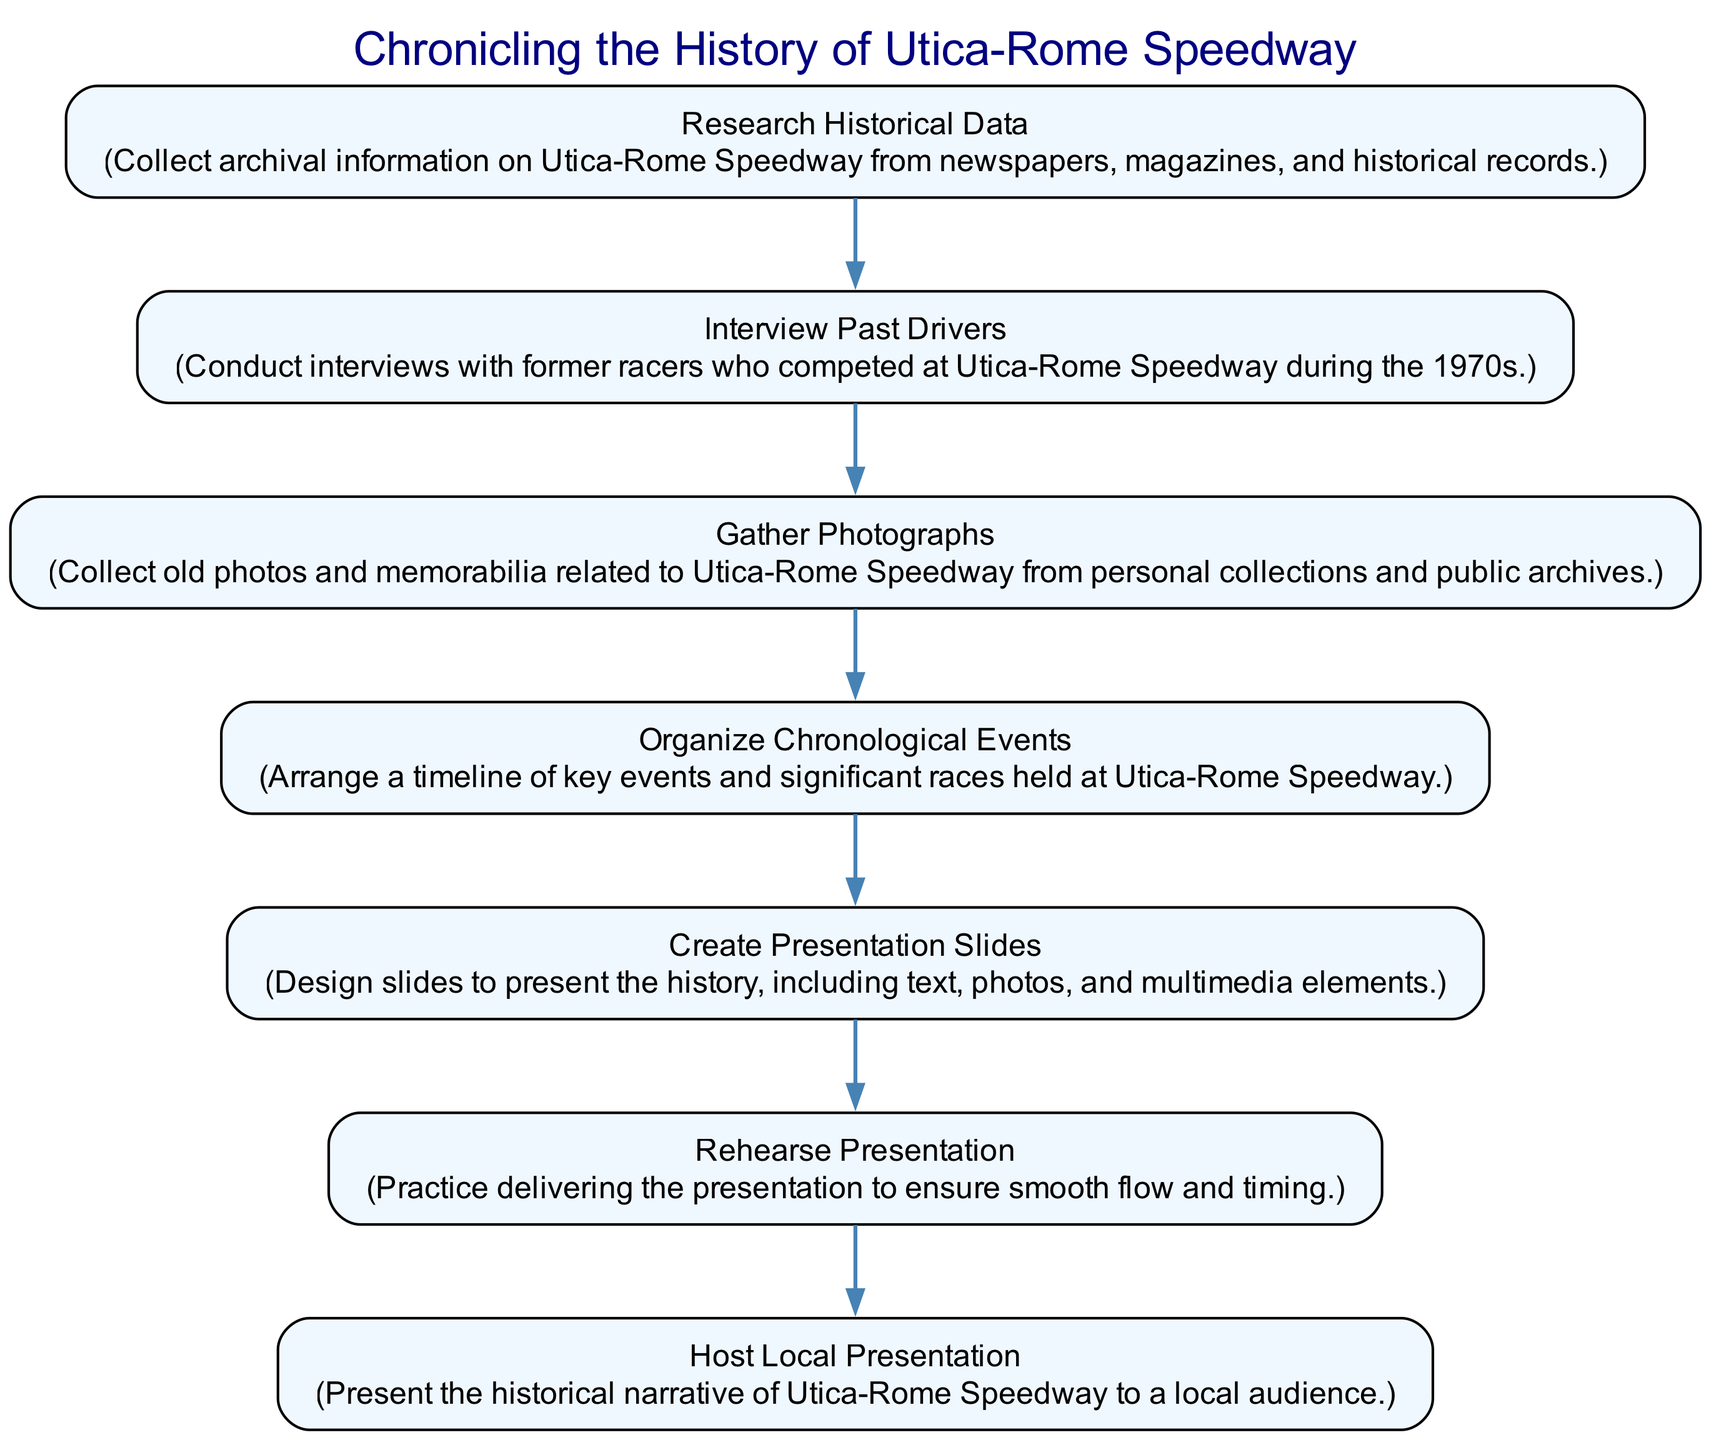What is the first activity in the diagram? The first activity listed in the diagram is "Research Historical Data". This can be identified as it is the starting point before any transitions occur, making it the initial node depicted in the diagram.
Answer: Research Historical Data How many total activities are in the diagram? There are six activities listed in the diagram, which can be counted by identifying each unique node presented. Each node represents a distinct activity involved in chronicling the history of Utica-Rome Speedway.
Answer: 6 What is the last step before hosting the local presentation? The last step before hosting the local presentation is "Rehearse Presentation". This step comes right before the final transition to the overall hosting activity indicated in the diagram.
Answer: Rehearse Presentation Which activity follows "Gather Photographs"? The activity that follows "Gather Photographs" is "Organize Chronological Events". This is directly inferred from the transition that moves from the photograph gathering node to the chronological organization node in the flow of the diagram.
Answer: Organize Chronological Events How many edges connect the activities in the diagram? There are five edges connecting the activities in the diagram. Each edge represents a transition from one activity to the next, which can be counted directly from the connections shown between the activity nodes.
Answer: 5 What is the purpose of the "Create Presentation Slides" activity? The purpose of the "Create Presentation Slides" activity is to design slides that present the history of Utica-Rome Speedway, incorporating text, photos, and multimedia elements. This is detailed in the description provided within the node's representation in the diagram.
Answer: Design slides Which two activities are linked to "Interview Past Drivers"? The two activities linked to "Interview Past Drivers" are "Research Historical Data" and "Gather Photographs". The first is a precursor, and the second is a subsequent activity, based on the directional transitions shown in the diagram.
Answer: Research Historical Data and Gather Photographs What color represents the nodes in the diagram? The nodes in the diagram are represented with a light blue color, specifically #F0F8FF, which is indicated by the node attribute settings within the diagram setup.
Answer: Light blue 